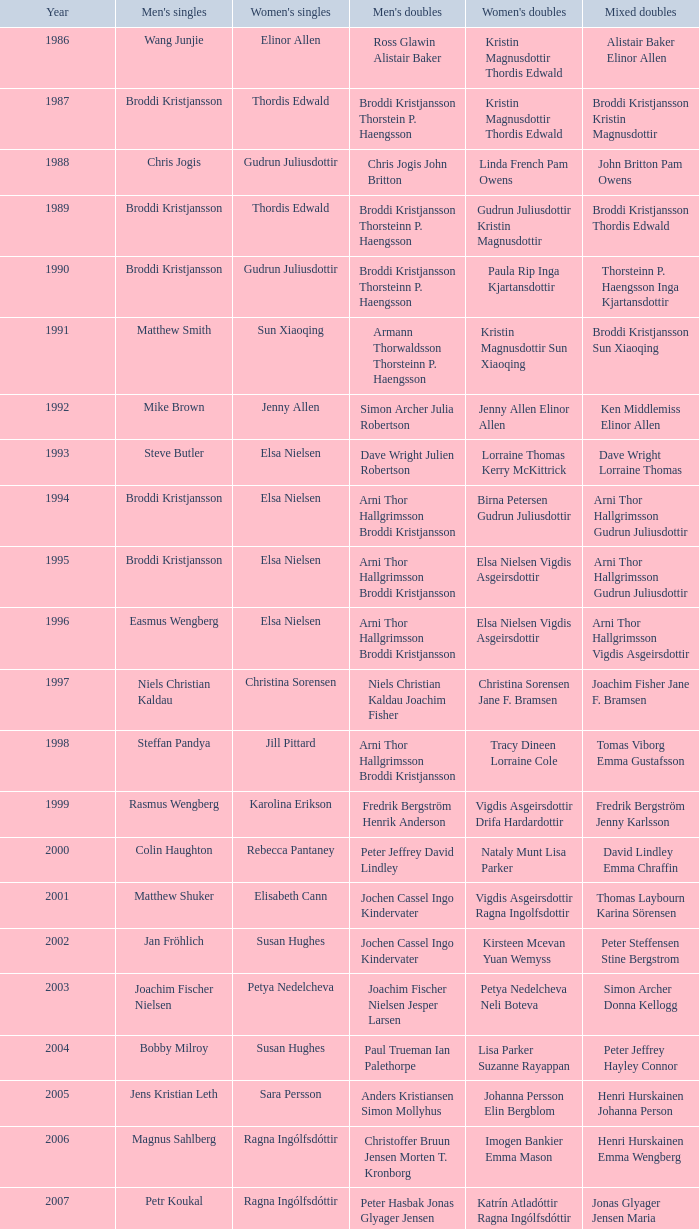In which women's doubles did Wang Junjie play men's singles? Kristin Magnusdottir Thordis Edwald. 